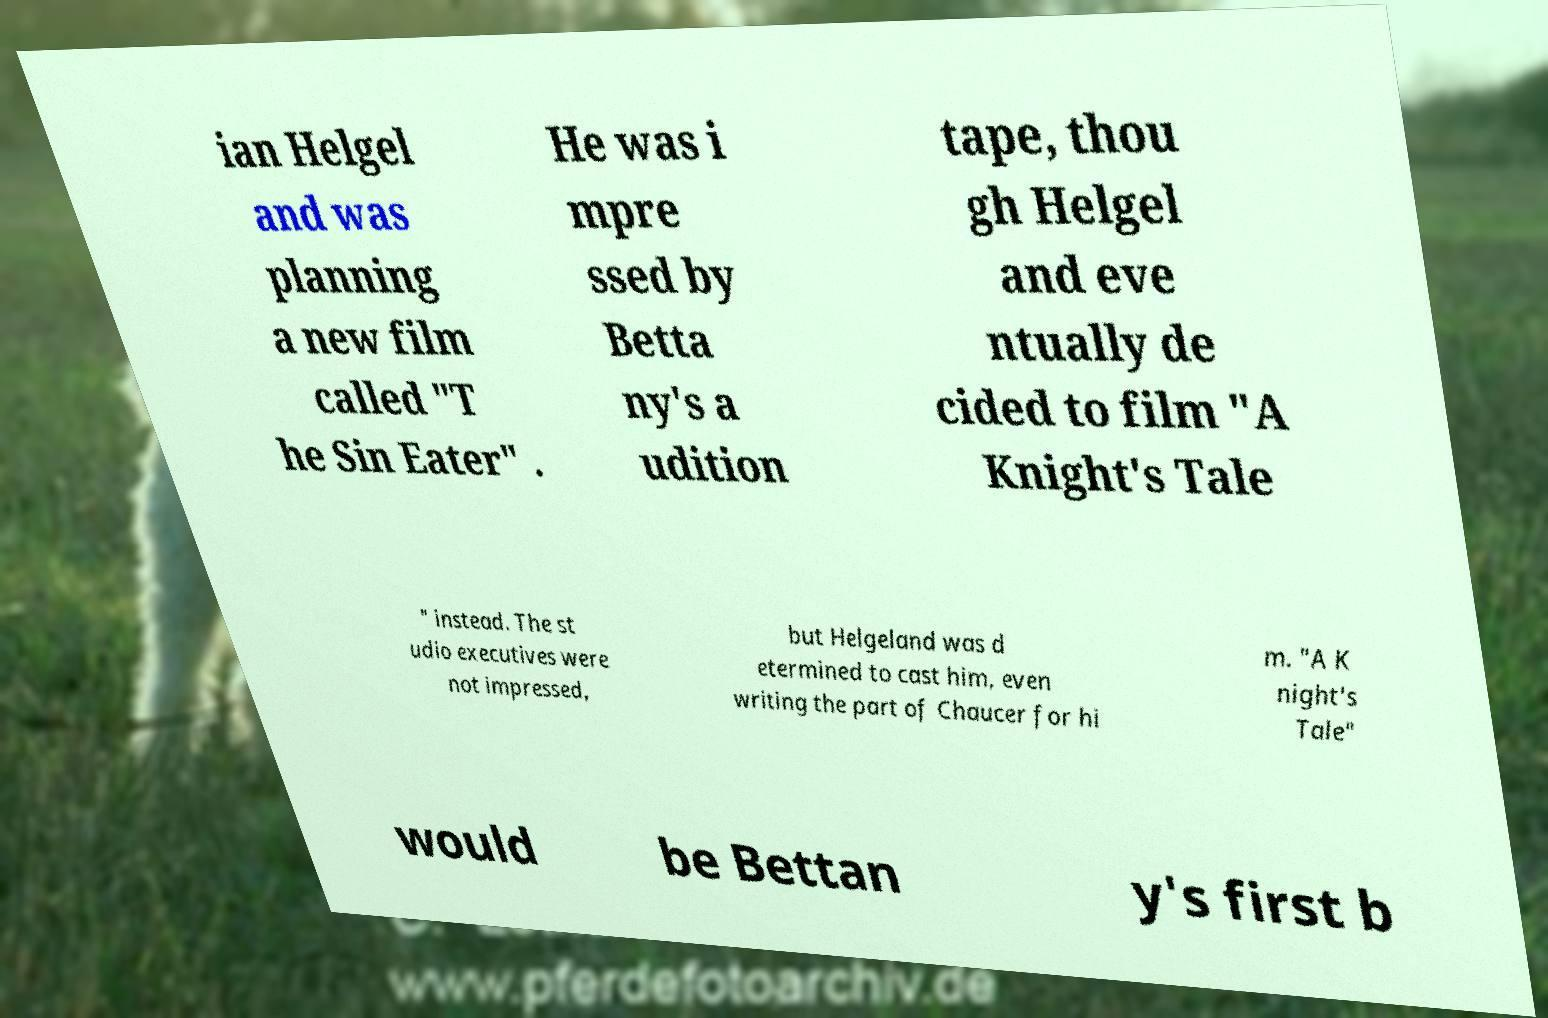For documentation purposes, I need the text within this image transcribed. Could you provide that? ian Helgel and was planning a new film called "T he Sin Eater" . He was i mpre ssed by Betta ny's a udition tape, thou gh Helgel and eve ntually de cided to film "A Knight's Tale " instead. The st udio executives were not impressed, but Helgeland was d etermined to cast him, even writing the part of Chaucer for hi m. "A K night's Tale" would be Bettan y's first b 